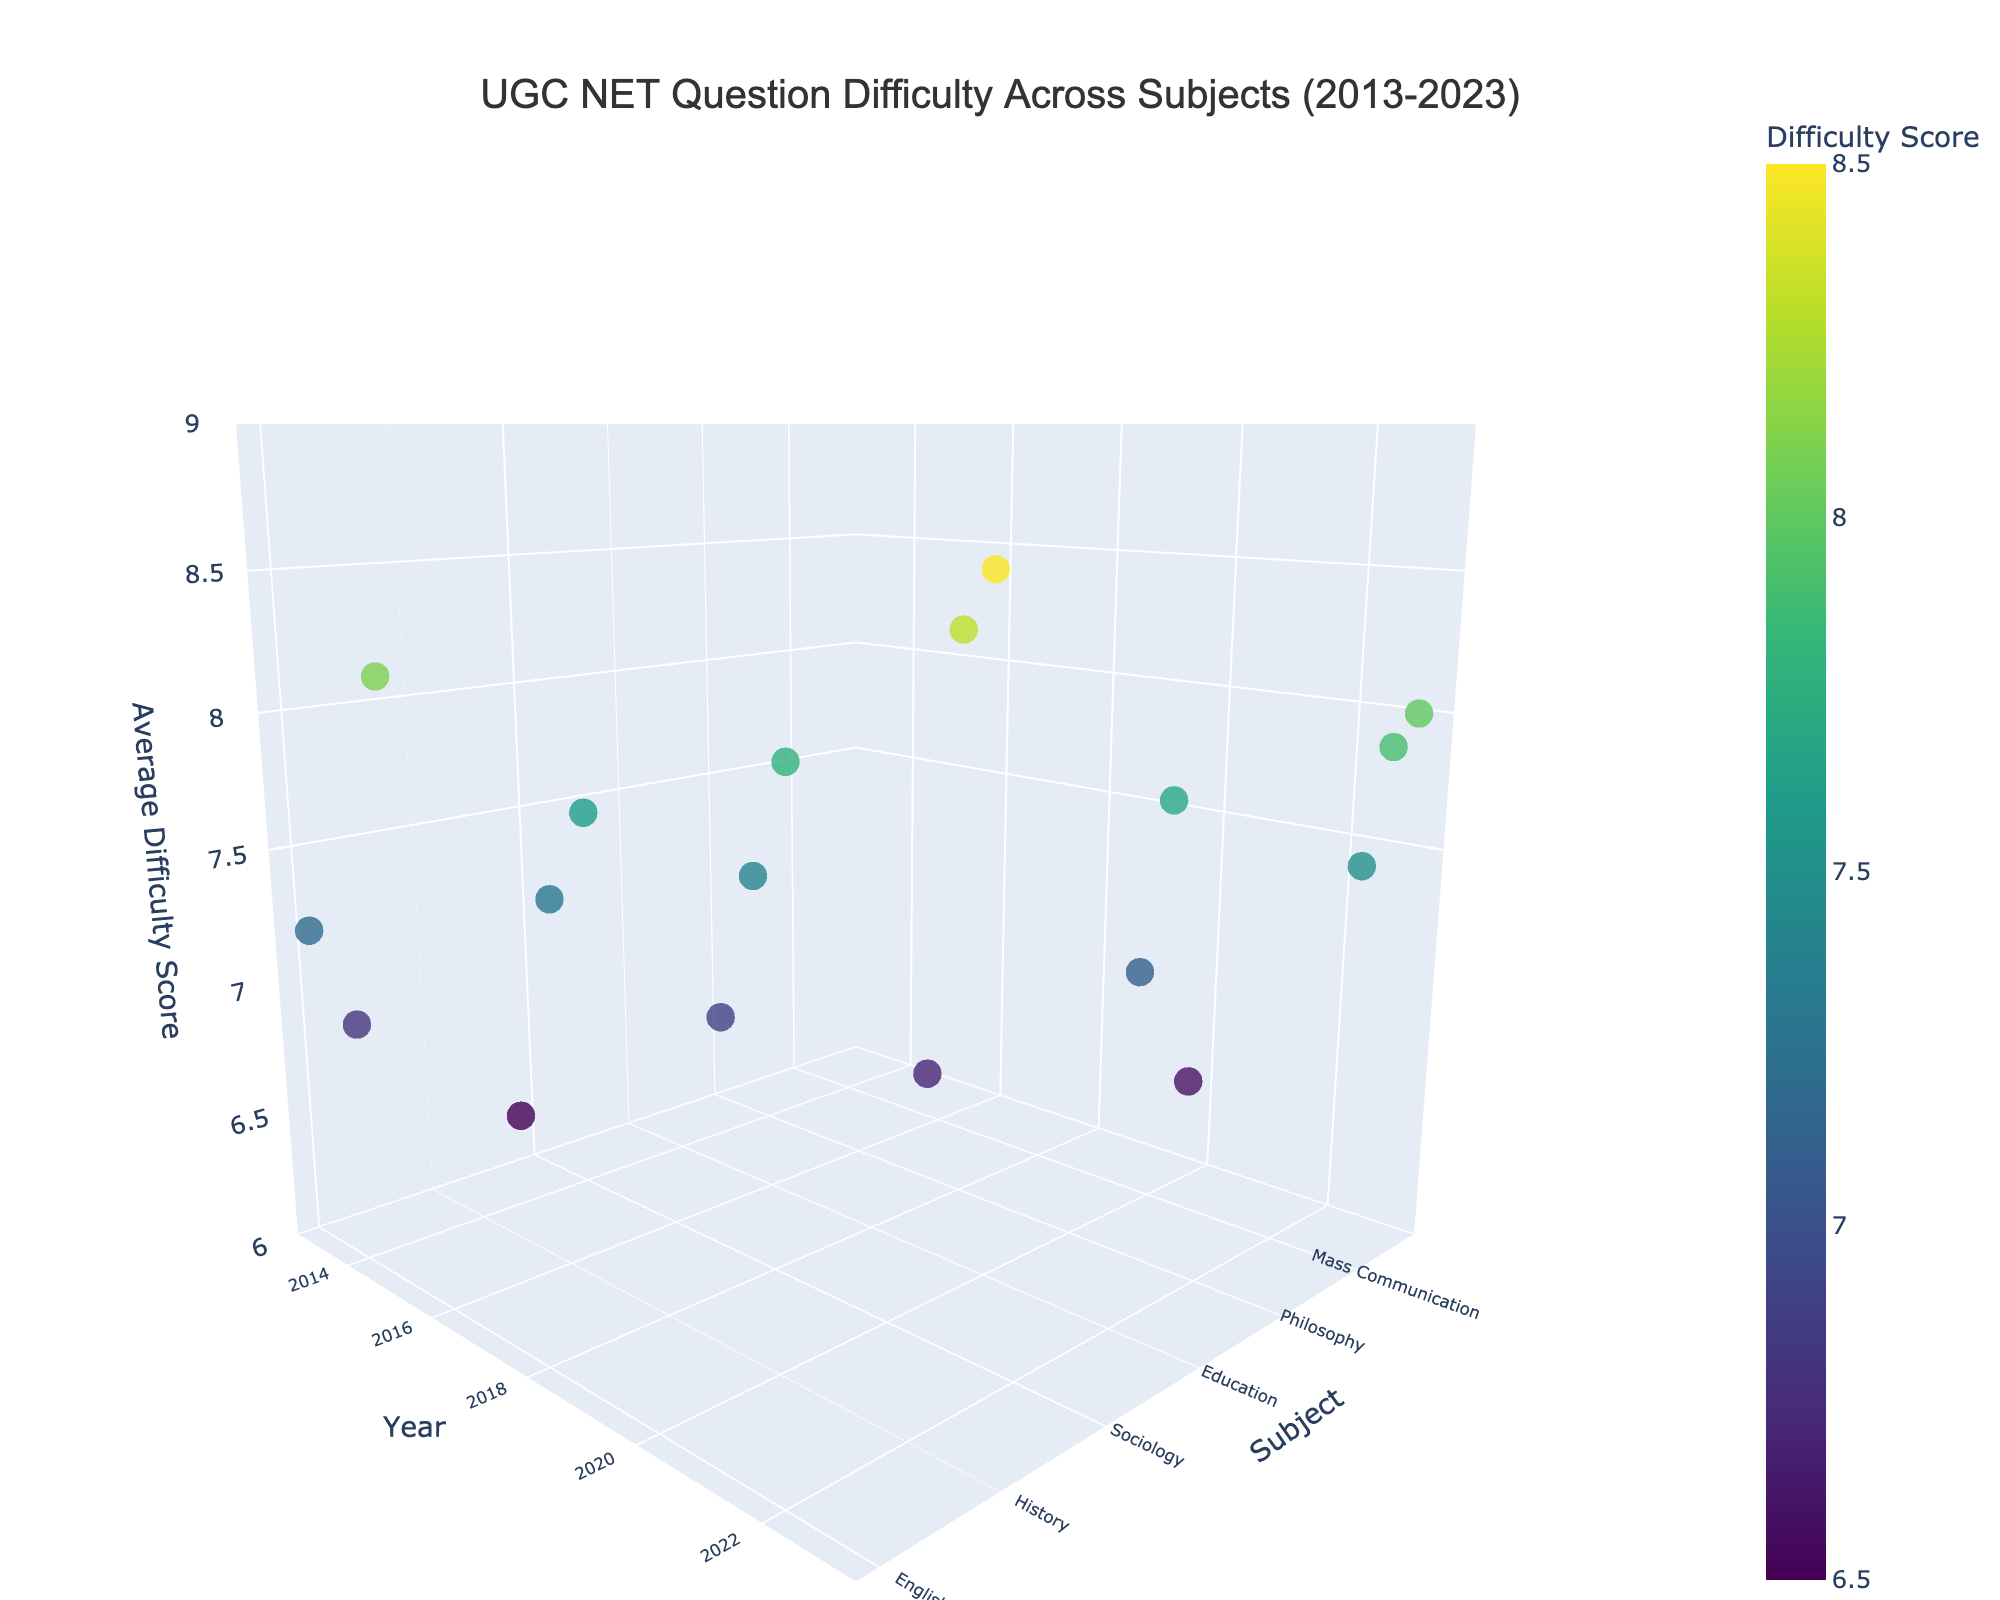What is the title of the 3D plot? The title of a plot is usually displayed at the top and provides a quick overview of what the plot is about. In this case, it helps viewers understand that the plot is related to UGC NET question difficulty across subjects over a particular time frame.
Answer: UGC NET Question Difficulty Across Subjects (2013-2023) Which subject had the highest average difficulty score in 2019? To answer this question, you need to look at the z-axis values (average difficulty score) for the year 2019 data points and identify the subject with the highest score.
Answer: Law How many subjects have an average difficulty score greater than 8.0? Check the z-axis values to count the number of data points (subjects) that have a score greater than 8.0 across all years.
Answer: 4 Which year had the most subjects included in the data? Count the number of data points for each year visible on the x-axis to find out which year has the highest number.
Answer: 2023 Compare the average difficulty scores between Linguistics in 2023 and Computer Science in 2013. Which one is higher? Identify the z-axis values for both Linguistics in 2023 and Computer Science in 2013, then compare them to see which one is higher.
Answer: Linguistics What is the average difficulty score for subjects in the year 2021? Find the z-axis values for all subjects in 2021, sum them up and divide by the number of subjects to calculate the average difficulty score.
Answer: 7.13 Which subject has the lowest average difficulty score, and in which year? Look for the data point with the lowest z-axis value and note the corresponding subject and year from the y-axis and x-axis, respectively.
Answer: Library Science, 2021 Are there more subjects with difficulty scores above 7.5 in the year 2023 or 2019? Count the number of data points with z-axis values above 7.5 for both years and compare the counts.
Answer: 2023 What is the trend in average difficulty scores for the subject English from the data provided? Identify the data points corresponding to English and observe the changes in z-axis values over the years to determine if the scores are increasing, decreasing, or stable.
Answer: No trend observable (only one data point for English in 2013) Is there any subject with a difficulty score that remained constant across multiple years? Check for any subjects with data points that have the same z-axis value across different years.
Answer: No 